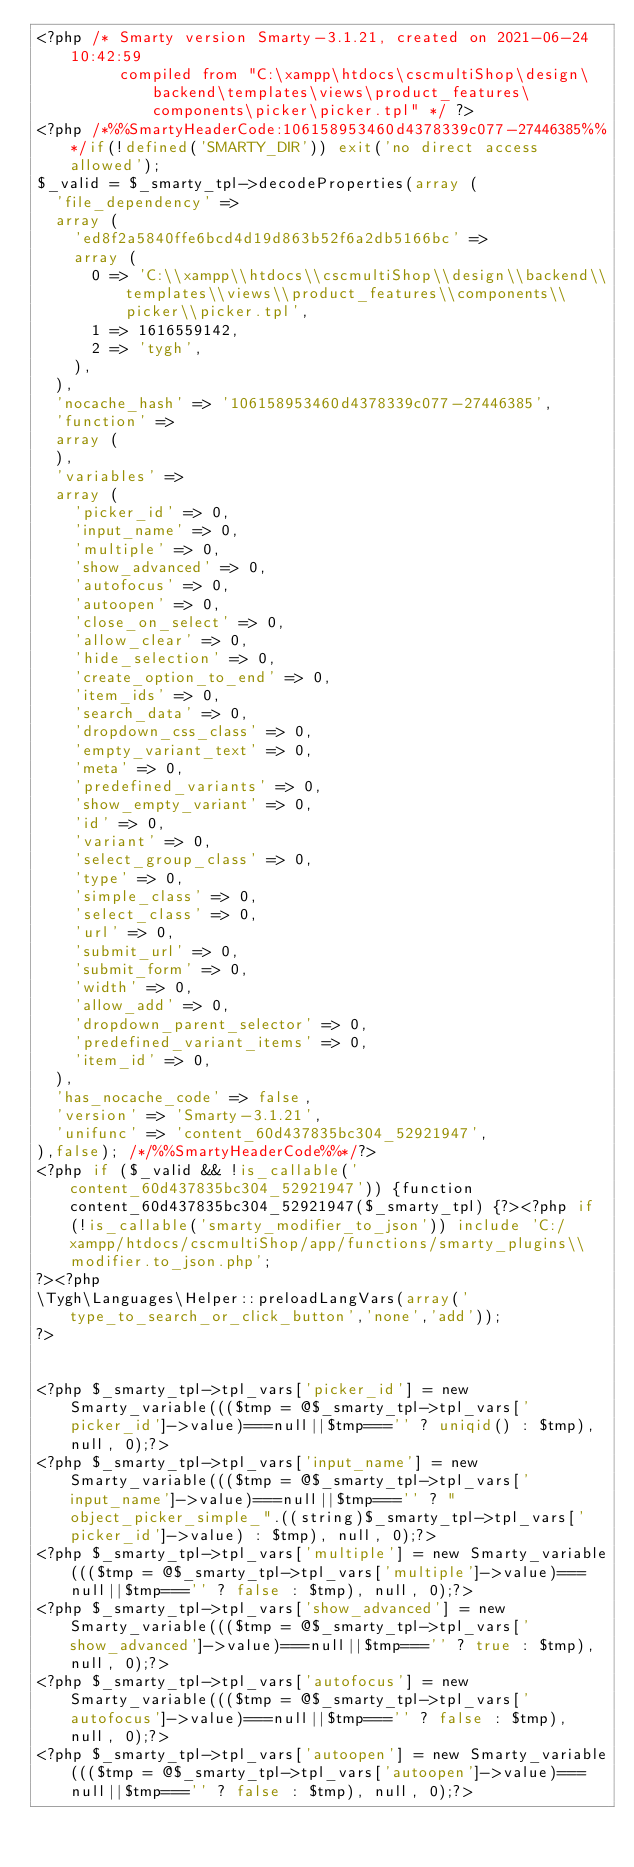<code> <loc_0><loc_0><loc_500><loc_500><_PHP_><?php /* Smarty version Smarty-3.1.21, created on 2021-06-24 10:42:59
         compiled from "C:\xampp\htdocs\cscmultiShop\design\backend\templates\views\product_features\components\picker\picker.tpl" */ ?>
<?php /*%%SmartyHeaderCode:106158953460d4378339c077-27446385%%*/if(!defined('SMARTY_DIR')) exit('no direct access allowed');
$_valid = $_smarty_tpl->decodeProperties(array (
  'file_dependency' => 
  array (
    'ed8f2a5840ffe6bcd4d19d863b52f6a2db5166bc' => 
    array (
      0 => 'C:\\xampp\\htdocs\\cscmultiShop\\design\\backend\\templates\\views\\product_features\\components\\picker\\picker.tpl',
      1 => 1616559142,
      2 => 'tygh',
    ),
  ),
  'nocache_hash' => '106158953460d4378339c077-27446385',
  'function' => 
  array (
  ),
  'variables' => 
  array (
    'picker_id' => 0,
    'input_name' => 0,
    'multiple' => 0,
    'show_advanced' => 0,
    'autofocus' => 0,
    'autoopen' => 0,
    'close_on_select' => 0,
    'allow_clear' => 0,
    'hide_selection' => 0,
    'create_option_to_end' => 0,
    'item_ids' => 0,
    'search_data' => 0,
    'dropdown_css_class' => 0,
    'empty_variant_text' => 0,
    'meta' => 0,
    'predefined_variants' => 0,
    'show_empty_variant' => 0,
    'id' => 0,
    'variant' => 0,
    'select_group_class' => 0,
    'type' => 0,
    'simple_class' => 0,
    'select_class' => 0,
    'url' => 0,
    'submit_url' => 0,
    'submit_form' => 0,
    'width' => 0,
    'allow_add' => 0,
    'dropdown_parent_selector' => 0,
    'predefined_variant_items' => 0,
    'item_id' => 0,
  ),
  'has_nocache_code' => false,
  'version' => 'Smarty-3.1.21',
  'unifunc' => 'content_60d437835bc304_52921947',
),false); /*/%%SmartyHeaderCode%%*/?>
<?php if ($_valid && !is_callable('content_60d437835bc304_52921947')) {function content_60d437835bc304_52921947($_smarty_tpl) {?><?php if (!is_callable('smarty_modifier_to_json')) include 'C:/xampp/htdocs/cscmultiShop/app/functions/smarty_plugins\\modifier.to_json.php';
?><?php
\Tygh\Languages\Helper::preloadLangVars(array('type_to_search_or_click_button','none','add'));
?>


<?php $_smarty_tpl->tpl_vars['picker_id'] = new Smarty_variable((($tmp = @$_smarty_tpl->tpl_vars['picker_id']->value)===null||$tmp==='' ? uniqid() : $tmp), null, 0);?>
<?php $_smarty_tpl->tpl_vars['input_name'] = new Smarty_variable((($tmp = @$_smarty_tpl->tpl_vars['input_name']->value)===null||$tmp==='' ? "object_picker_simple_".((string)$_smarty_tpl->tpl_vars['picker_id']->value) : $tmp), null, 0);?>
<?php $_smarty_tpl->tpl_vars['multiple'] = new Smarty_variable((($tmp = @$_smarty_tpl->tpl_vars['multiple']->value)===null||$tmp==='' ? false : $tmp), null, 0);?>
<?php $_smarty_tpl->tpl_vars['show_advanced'] = new Smarty_variable((($tmp = @$_smarty_tpl->tpl_vars['show_advanced']->value)===null||$tmp==='' ? true : $tmp), null, 0);?>
<?php $_smarty_tpl->tpl_vars['autofocus'] = new Smarty_variable((($tmp = @$_smarty_tpl->tpl_vars['autofocus']->value)===null||$tmp==='' ? false : $tmp), null, 0);?>
<?php $_smarty_tpl->tpl_vars['autoopen'] = new Smarty_variable((($tmp = @$_smarty_tpl->tpl_vars['autoopen']->value)===null||$tmp==='' ? false : $tmp), null, 0);?></code> 